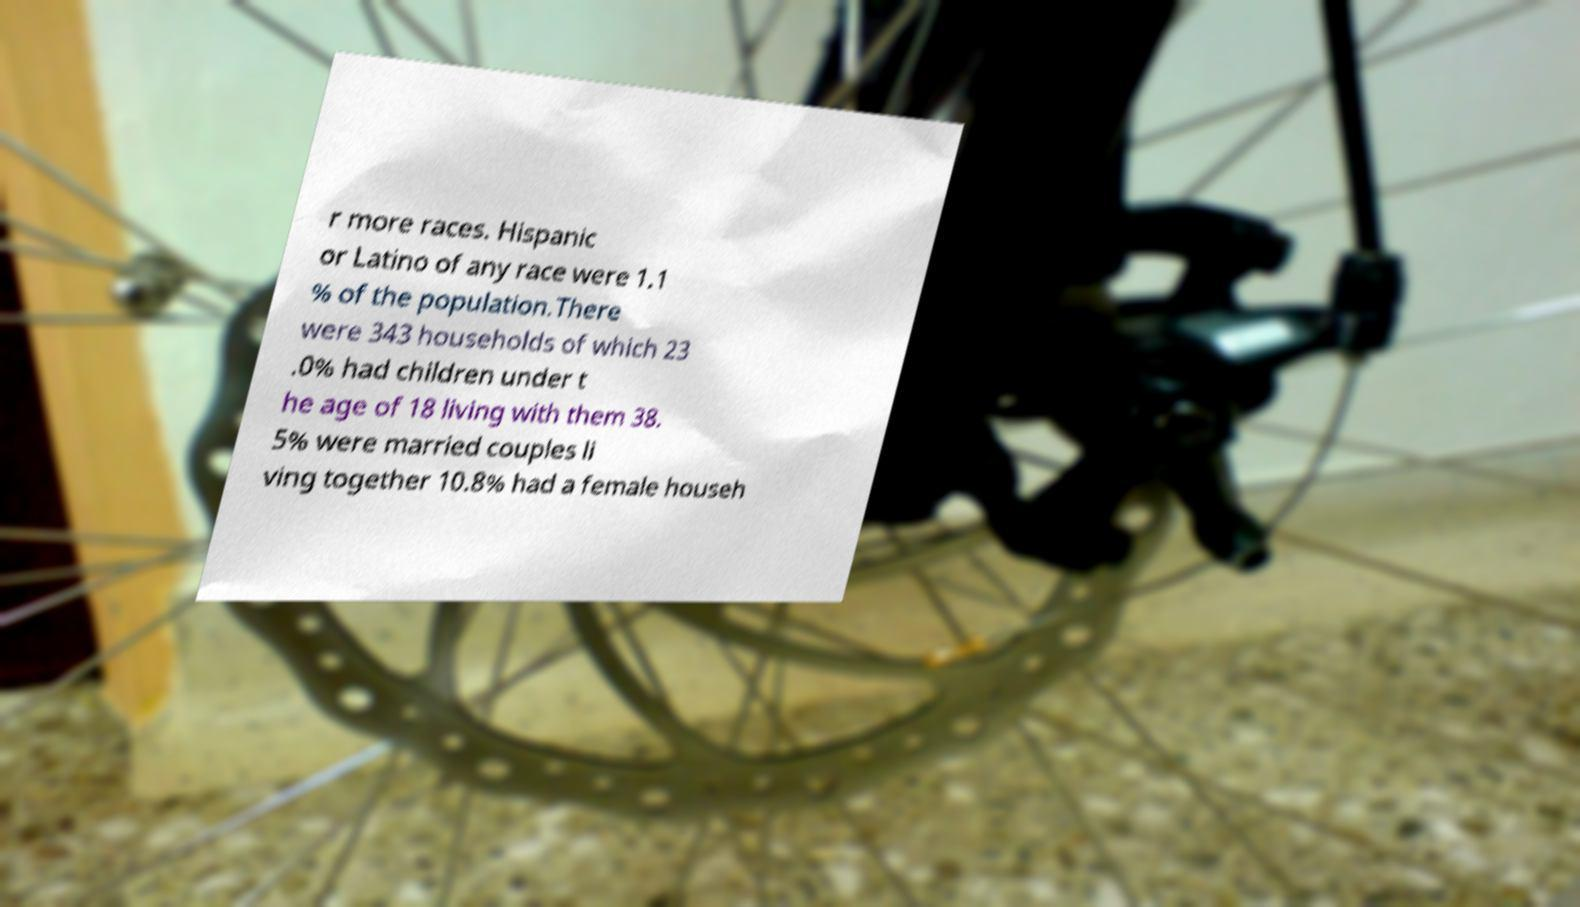Could you extract and type out the text from this image? r more races. Hispanic or Latino of any race were 1.1 % of the population.There were 343 households of which 23 .0% had children under t he age of 18 living with them 38. 5% were married couples li ving together 10.8% had a female househ 